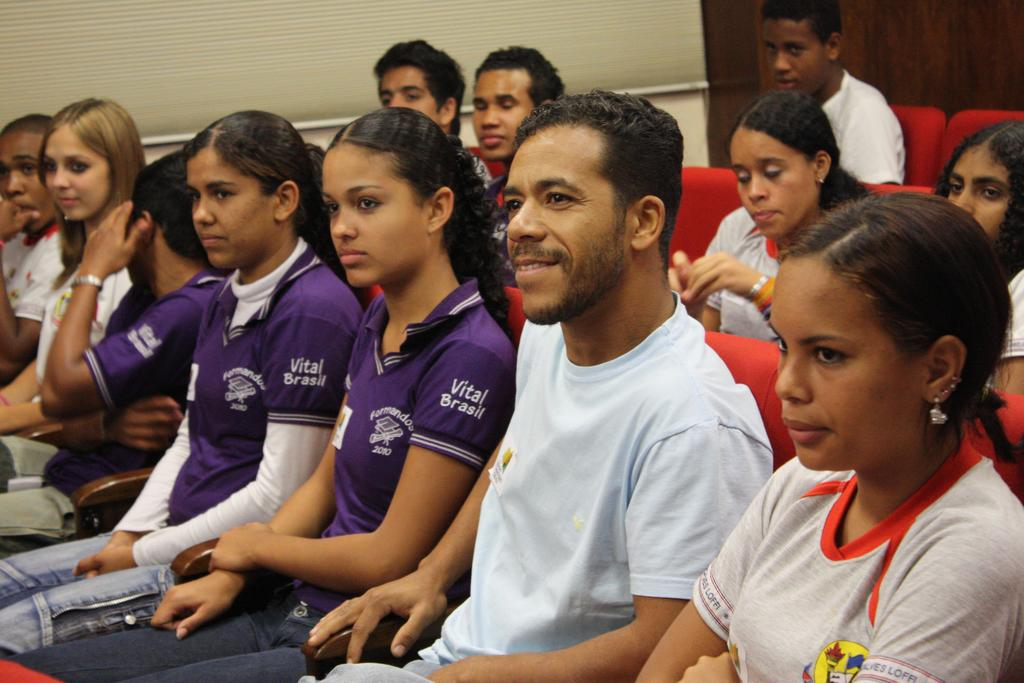Who is present in the image? There are men and women in the image. What are the men and women sitting on? The men and women are sitting on red color seats. What can be seen in the background of the image? There is a white and brown color wall in the background. What type of knot is being tied by the men and women in the image? There is no knot being tied in the image; the men and women are sitting on red color seats. 